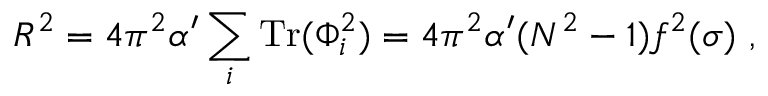<formula> <loc_0><loc_0><loc_500><loc_500>R ^ { 2 } = { 4 \pi ^ { 2 } \alpha ^ { \prime } } \sum _ { i } T r ( \Phi _ { i } ^ { 2 } ) = { 4 \pi ^ { 2 } \alpha ^ { \prime } } ( N ^ { 2 } - 1 ) f ^ { 2 } ( \sigma ) \ ,</formula> 